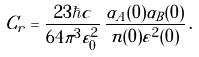<formula> <loc_0><loc_0><loc_500><loc_500>C _ { r } = \frac { 2 3 \hbar { c } } { 6 4 \pi ^ { 3 } \varepsilon _ { 0 } ^ { 2 } } \, \frac { \alpha _ { A } ( 0 ) \alpha _ { B } ( 0 ) } { n ( 0 ) \varepsilon ^ { 2 } ( 0 ) } \, .</formula> 